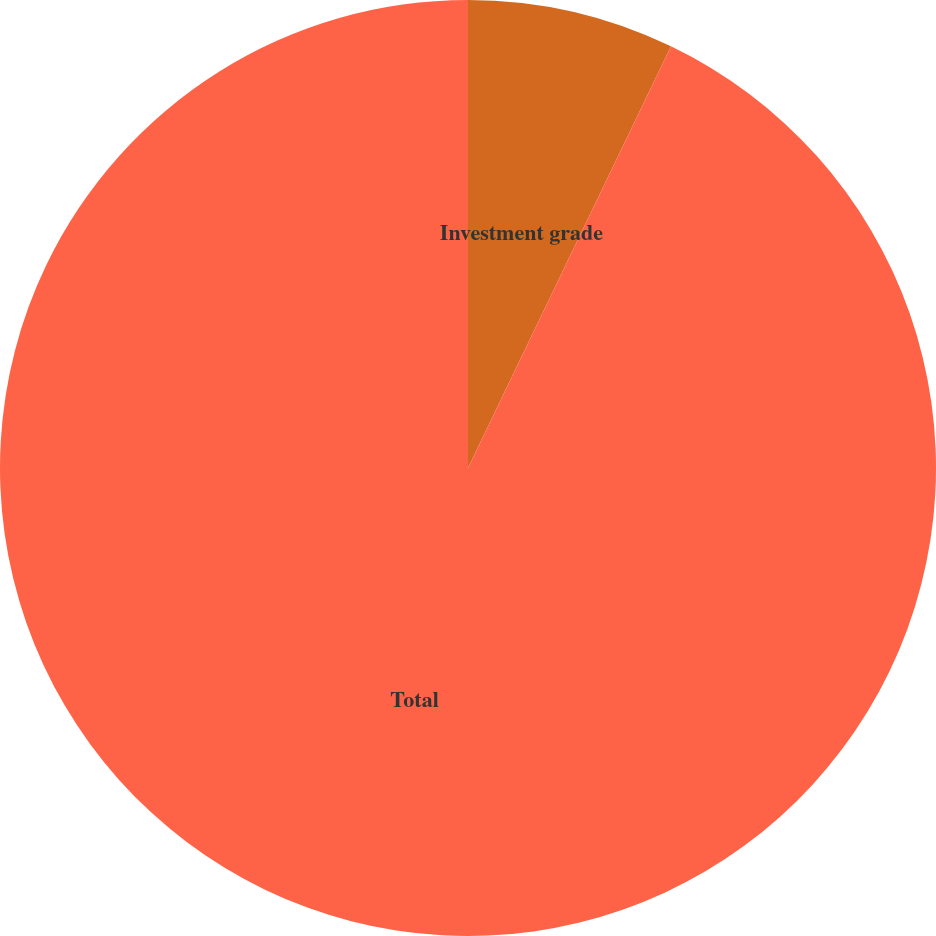Convert chart to OTSL. <chart><loc_0><loc_0><loc_500><loc_500><pie_chart><fcel>Investment grade<fcel>Total<nl><fcel>7.14%<fcel>92.86%<nl></chart> 